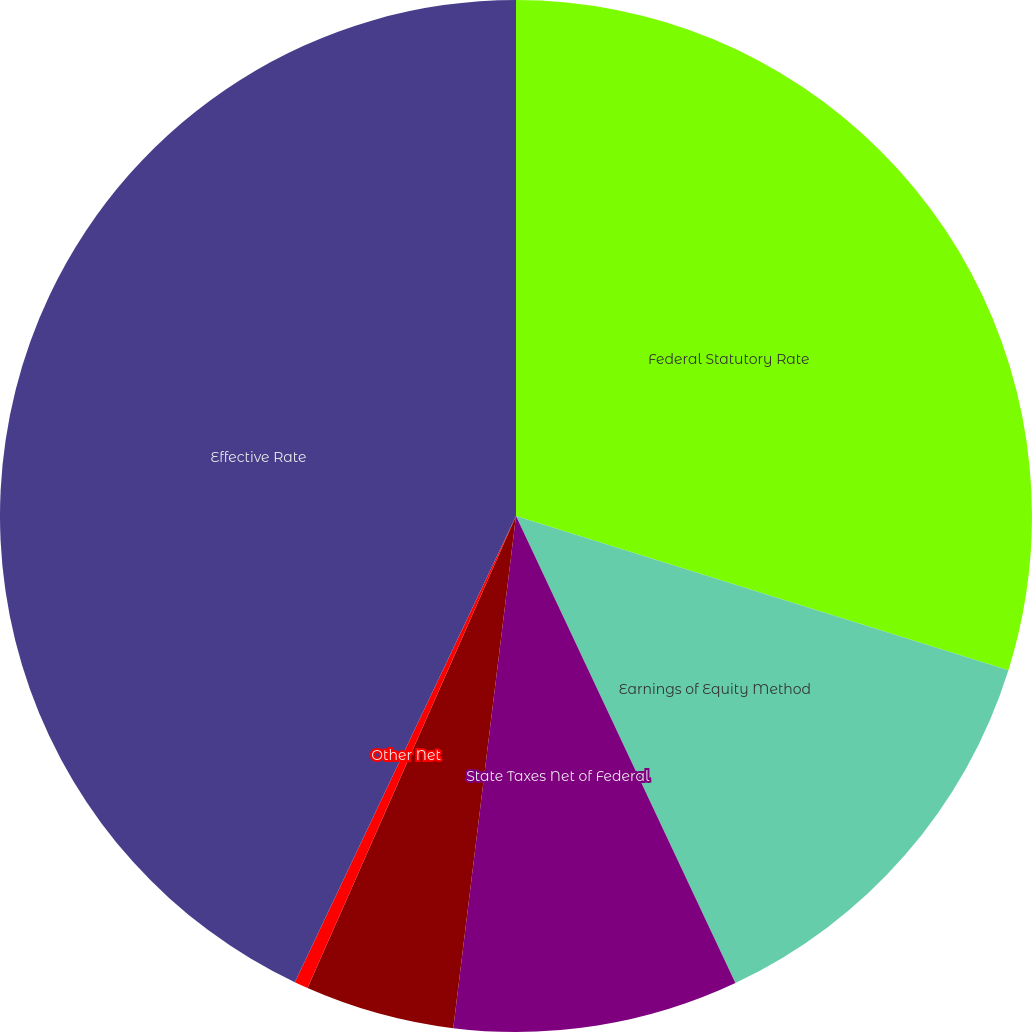Convert chart. <chart><loc_0><loc_0><loc_500><loc_500><pie_chart><fcel>Federal Statutory Rate<fcel>Earnings of Equity Method<fcel>State Taxes Net of Federal<fcel>Difference Betw een US and<fcel>Other Net<fcel>Effective Rate<nl><fcel>29.83%<fcel>13.18%<fcel>8.93%<fcel>4.68%<fcel>0.43%<fcel>42.95%<nl></chart> 